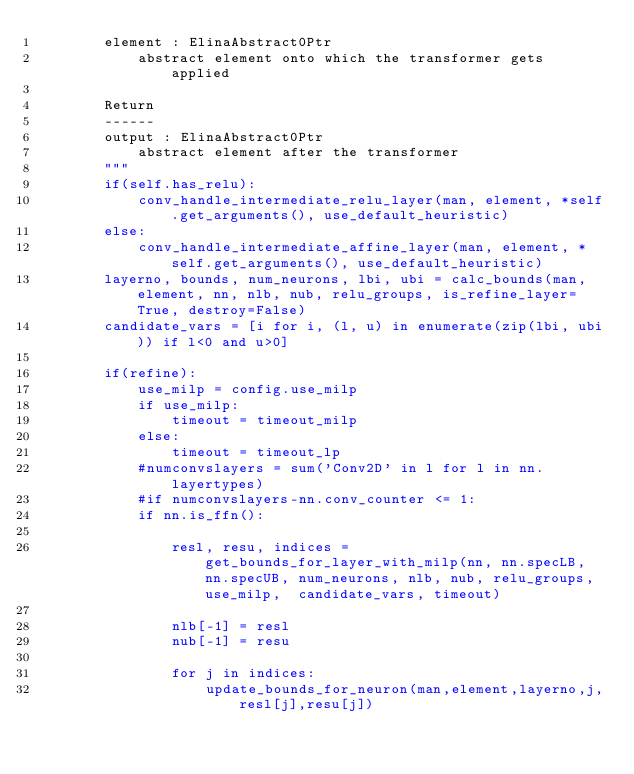<code> <loc_0><loc_0><loc_500><loc_500><_Python_>        element : ElinaAbstract0Ptr
            abstract element onto which the transformer gets applied
        
        Return
        ------
        output : ElinaAbstract0Ptr
            abstract element after the transformer 
        """
        if(self.has_relu):
            conv_handle_intermediate_relu_layer(man, element, *self.get_arguments(), use_default_heuristic)
        else:
            conv_handle_intermediate_affine_layer(man, element, *self.get_arguments(), use_default_heuristic)
        layerno, bounds, num_neurons, lbi, ubi = calc_bounds(man, element, nn, nlb, nub, relu_groups, is_refine_layer=True, destroy=False)
        candidate_vars = [i for i, (l, u) in enumerate(zip(lbi, ubi)) if l<0 and u>0]

        if(refine):
            use_milp = config.use_milp
            if use_milp:
                timeout = timeout_milp
            else:
                timeout = timeout_lp
            #numconvslayers = sum('Conv2D' in l for l in nn.layertypes)
            #if numconvslayers-nn.conv_counter <= 1:
            if nn.is_ffn():

                resl, resu, indices = get_bounds_for_layer_with_milp(nn, nn.specLB, nn.specUB, num_neurons, nlb, nub, relu_groups, use_milp,  candidate_vars, timeout)

                nlb[-1] = resl
                nub[-1] = resu

                for j in indices:
                    update_bounds_for_neuron(man,element,layerno,j,resl[j],resu[j])
</code> 